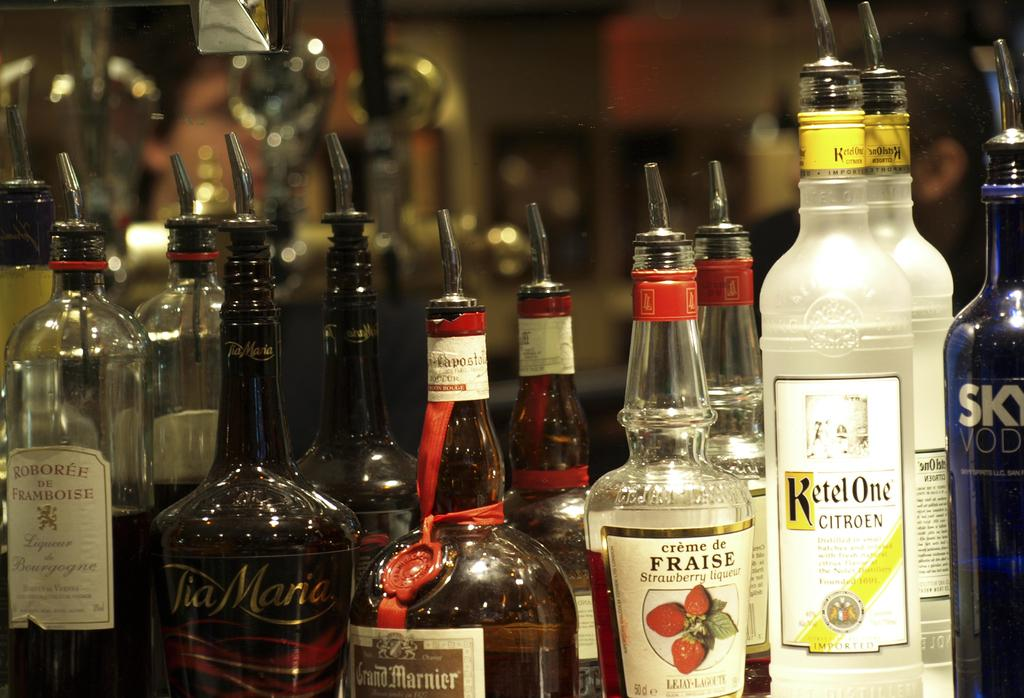<image>
Describe the image concisely. Alcohol bottles on a counter with one that says FRAISE. 